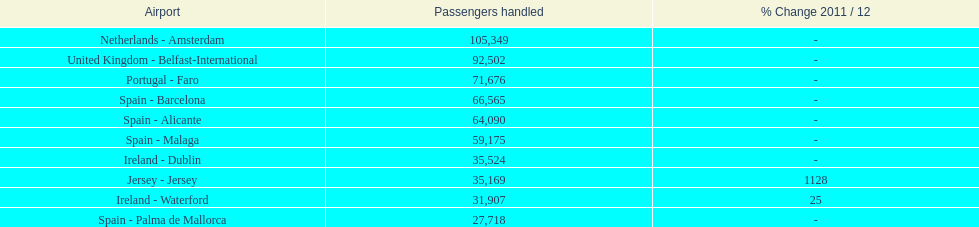Which airport has the least amount of passengers going through london southend airport? Spain - Palma de Mallorca. 